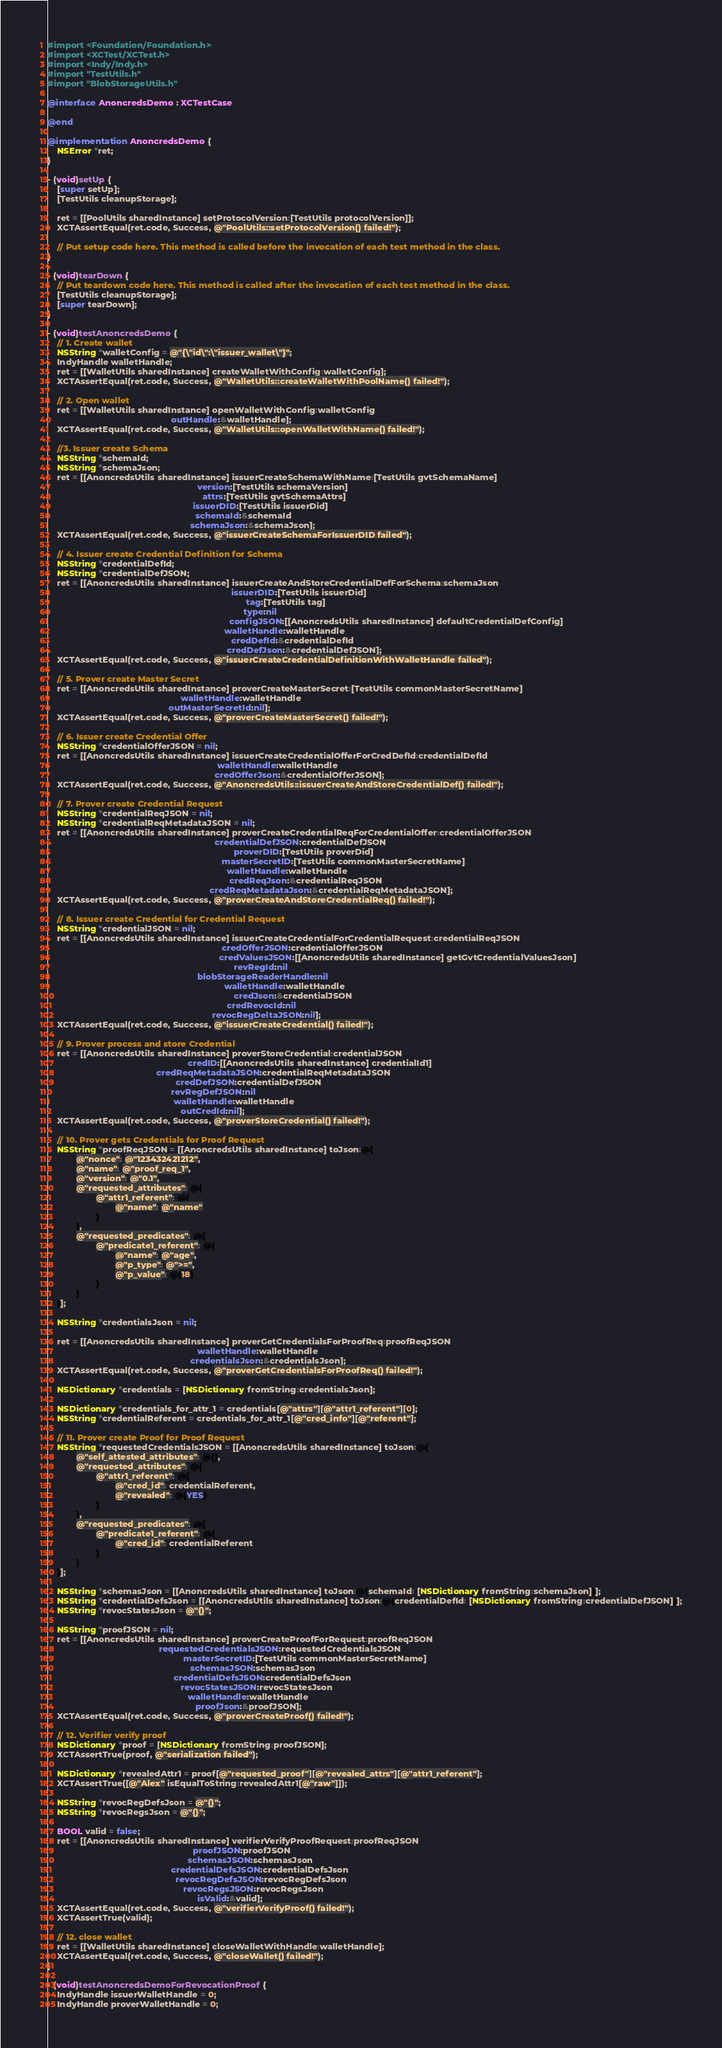Convert code to text. <code><loc_0><loc_0><loc_500><loc_500><_ObjectiveC_>#import <Foundation/Foundation.h>
#import <XCTest/XCTest.h>
#import <Indy/Indy.h>
#import "TestUtils.h"
#import "BlobStorageUtils.h"

@interface AnoncredsDemo : XCTestCase

@end

@implementation AnoncredsDemo {
    NSError *ret;
}

- (void)setUp {
    [super setUp];
    [TestUtils cleanupStorage];

    ret = [[PoolUtils sharedInstance] setProtocolVersion:[TestUtils protocolVersion]];
    XCTAssertEqual(ret.code, Success, @"PoolUtils::setProtocolVersion() failed!");

    // Put setup code here. This method is called before the invocation of each test method in the class.
}

- (void)tearDown {
    // Put teardown code here. This method is called after the invocation of each test method in the class.
    [TestUtils cleanupStorage];
    [super tearDown];
}

- (void)testAnoncredsDemo {
    // 1. Create wallet
    NSString *walletConfig = @"{\"id\":\"issuer_wallet\"}";
    IndyHandle walletHandle;
    ret = [[WalletUtils sharedInstance] createWalletWithConfig:walletConfig];
    XCTAssertEqual(ret.code, Success, @"WalletUtils::createWalletWithPoolName() failed!");

    // 2. Open wallet
    ret = [[WalletUtils sharedInstance] openWalletWithConfig:walletConfig
                                                   outHandle:&walletHandle];
    XCTAssertEqual(ret.code, Success, @"WalletUtils::openWalletWithName() failed!");

    //3. Issuer create Schema
    NSString *schemaId;
    NSString *schemaJson;
    ret = [[AnoncredsUtils sharedInstance] issuerCreateSchemaWithName:[TestUtils gvtSchemaName]
                                                              version:[TestUtils schemaVersion]
                                                                attrs:[TestUtils gvtSchemaAttrs]
                                                            issuerDID:[TestUtils issuerDid]
                                                             schemaId:&schemaId
                                                           schemaJson:&schemaJson];
    XCTAssertEqual(ret.code, Success, @"issuerCreateSchemaForIssuerDID failed");

    // 4. Issuer create Credential Definition for Schema
    NSString *credentialDefId;
    NSString *credentialDefJSON;
    ret = [[AnoncredsUtils sharedInstance] issuerCreateAndStoreCredentialDefForSchema:schemaJson
                                                                            issuerDID:[TestUtils issuerDid]
                                                                                  tag:[TestUtils tag]
                                                                                 type:nil
                                                                           configJSON:[[AnoncredsUtils sharedInstance] defaultCredentialDefConfig]
                                                                         walletHandle:walletHandle
                                                                            credDefId:&credentialDefId
                                                                          credDefJson:&credentialDefJSON];
    XCTAssertEqual(ret.code, Success, @"issuerCreateCredentialDefinitionWithWalletHandle failed");

    // 5. Prover create Master Secret
    ret = [[AnoncredsUtils sharedInstance] proverCreateMasterSecret:[TestUtils commonMasterSecretName]
                                                       walletHandle:walletHandle
                                                  outMasterSecretId:nil];
    XCTAssertEqual(ret.code, Success, @"proverCreateMasterSecret() failed!");

    // 6. Issuer create Credential Offer
    NSString *credentialOfferJSON = nil;
    ret = [[AnoncredsUtils sharedInstance] issuerCreateCredentialOfferForCredDefId:credentialDefId
                                                                      walletHandle:walletHandle
                                                                     credOfferJson:&credentialOfferJSON];
    XCTAssertEqual(ret.code, Success, @"AnoncredsUtils::issuerCreateAndStoreCredentialDef() failed!");

    // 7. Prover create Credential Request
    NSString *credentialReqJSON = nil;
    NSString *credentialReqMetadataJSON = nil;
    ret = [[AnoncredsUtils sharedInstance] proverCreateCredentialReqForCredentialOffer:credentialOfferJSON
                                                                     credentialDefJSON:credentialDefJSON
                                                                             proverDID:[TestUtils proverDid]
                                                                        masterSecretID:[TestUtils commonMasterSecretName]
                                                                          walletHandle:walletHandle
                                                                           credReqJson:&credentialReqJSON
                                                                   credReqMetadataJson:&credentialReqMetadataJSON];
    XCTAssertEqual(ret.code, Success, @"proverCreateAndStoreCredentialReq() failed!");

    // 8. Issuer create Credential for Credential Request
    NSString *credentialJSON = nil;
    ret = [[AnoncredsUtils sharedInstance] issuerCreateCredentialForCredentialRequest:credentialReqJSON
                                                                        credOfferJSON:credentialOfferJSON
                                                                       credValuesJSON:[[AnoncredsUtils sharedInstance] getGvtCredentialValuesJson]
                                                                             revRegId:nil
                                                              blobStorageReaderHandle:nil
                                                                         walletHandle:walletHandle
                                                                             credJson:&credentialJSON
                                                                          credRevocId:nil
                                                                    revocRegDeltaJSON:nil];
    XCTAssertEqual(ret.code, Success, @"issuerCreateCredential() failed!");

    // 9. Prover process and store Credential
    ret = [[AnoncredsUtils sharedInstance] proverStoreCredential:credentialJSON
                                                          credID:[[AnoncredsUtils sharedInstance] credentialId1]
                                             credReqMetadataJSON:credentialReqMetadataJSON
                                                     credDefJSON:credentialDefJSON
                                                   revRegDefJSON:nil
                                                    walletHandle:walletHandle
                                                       outCredId:nil];
    XCTAssertEqual(ret.code, Success, @"proverStoreCredential() failed!");

    // 10. Prover gets Credentials for Proof Request
    NSString *proofReqJSON = [[AnoncredsUtils sharedInstance] toJson:@{
            @"nonce": @"123432421212",
            @"name": @"proof_req_1",
            @"version": @"0.1",
            @"requested_attributes": @{
                    @"attr1_referent": @{
                            @"name": @"name"
                    }
            },
            @"requested_predicates": @{
                    @"predicate1_referent": @{
                            @"name": @"age",
                            @"p_type": @">=",
                            @"p_value": @(18)
                    }
            }
    }];

    NSString *credentialsJson = nil;

    ret = [[AnoncredsUtils sharedInstance] proverGetCredentialsForProofReq:proofReqJSON
                                                              walletHandle:walletHandle
                                                           credentialsJson:&credentialsJson];
    XCTAssertEqual(ret.code, Success, @"proverGetCredentialsForProofReq() failed!");

    NSDictionary *credentials = [NSDictionary fromString:credentialsJson];

    NSDictionary *credentials_for_attr_1 = credentials[@"attrs"][@"attr1_referent"][0];
    NSString *credentialReferent = credentials_for_attr_1[@"cred_info"][@"referent"];

    // 11. Prover create Proof for Proof Request
    NSString *requestedCredentialsJSON = [[AnoncredsUtils sharedInstance] toJson:@{
            @"self_attested_attributes": @{},
            @"requested_attributes": @{
                    @"attr1_referent": @{
                            @"cred_id": credentialReferent,
                            @"revealed": @(YES)
                    }
            },
            @"requested_predicates": @{
                    @"predicate1_referent": @{
                            @"cred_id": credentialReferent
                    }
            }
    }];

    NSString *schemasJson = [[AnoncredsUtils sharedInstance] toJson:@{schemaId: [NSDictionary fromString:schemaJson]}];
    NSString *credentialDefsJson = [[AnoncredsUtils sharedInstance] toJson:@{credentialDefId: [NSDictionary fromString:credentialDefJSON]}];
    NSString *revocStatesJson = @"{}";

    NSString *proofJSON = nil;
    ret = [[AnoncredsUtils sharedInstance] proverCreateProofForRequest:proofReqJSON
                                              requestedCredentialsJSON:requestedCredentialsJSON
                                                        masterSecretID:[TestUtils commonMasterSecretName]
                                                           schemasJSON:schemasJson
                                                    credentialDefsJSON:credentialDefsJson
                                                       revocStatesJSON:revocStatesJson
                                                          walletHandle:walletHandle
                                                             proofJson:&proofJSON];
    XCTAssertEqual(ret.code, Success, @"proverCreateProof() failed!");

    // 12. Verifier verify proof
    NSDictionary *proof = [NSDictionary fromString:proofJSON];
    XCTAssertTrue(proof, @"serialization failed");

    NSDictionary *revealedAttr1 = proof[@"requested_proof"][@"revealed_attrs"][@"attr1_referent"];
    XCTAssertTrue([@"Alex" isEqualToString:revealedAttr1[@"raw"]]);

    NSString *revocRegDefsJson = @"{}";
    NSString *revocRegsJson = @"{}";

    BOOL valid = false;
    ret = [[AnoncredsUtils sharedInstance] verifierVerifyProofRequest:proofReqJSON
                                                            proofJSON:proofJSON
                                                          schemasJSON:schemasJson
                                                   credentialDefsJSON:credentialDefsJson
                                                     revocRegDefsJSON:revocRegDefsJson
                                                        revocRegsJSON:revocRegsJson
                                                              isValid:&valid];
    XCTAssertEqual(ret.code, Success, @"verifierVerifyProof() failed!");
    XCTAssertTrue(valid);

    // 12. close wallet
    ret = [[WalletUtils sharedInstance] closeWalletWithHandle:walletHandle];
    XCTAssertEqual(ret.code, Success, @"closeWallet() failed!");
}

- (void)testAnoncredsDemoForRevocationProof {
    IndyHandle issuerWalletHandle = 0;
    IndyHandle proverWalletHandle = 0;
</code> 